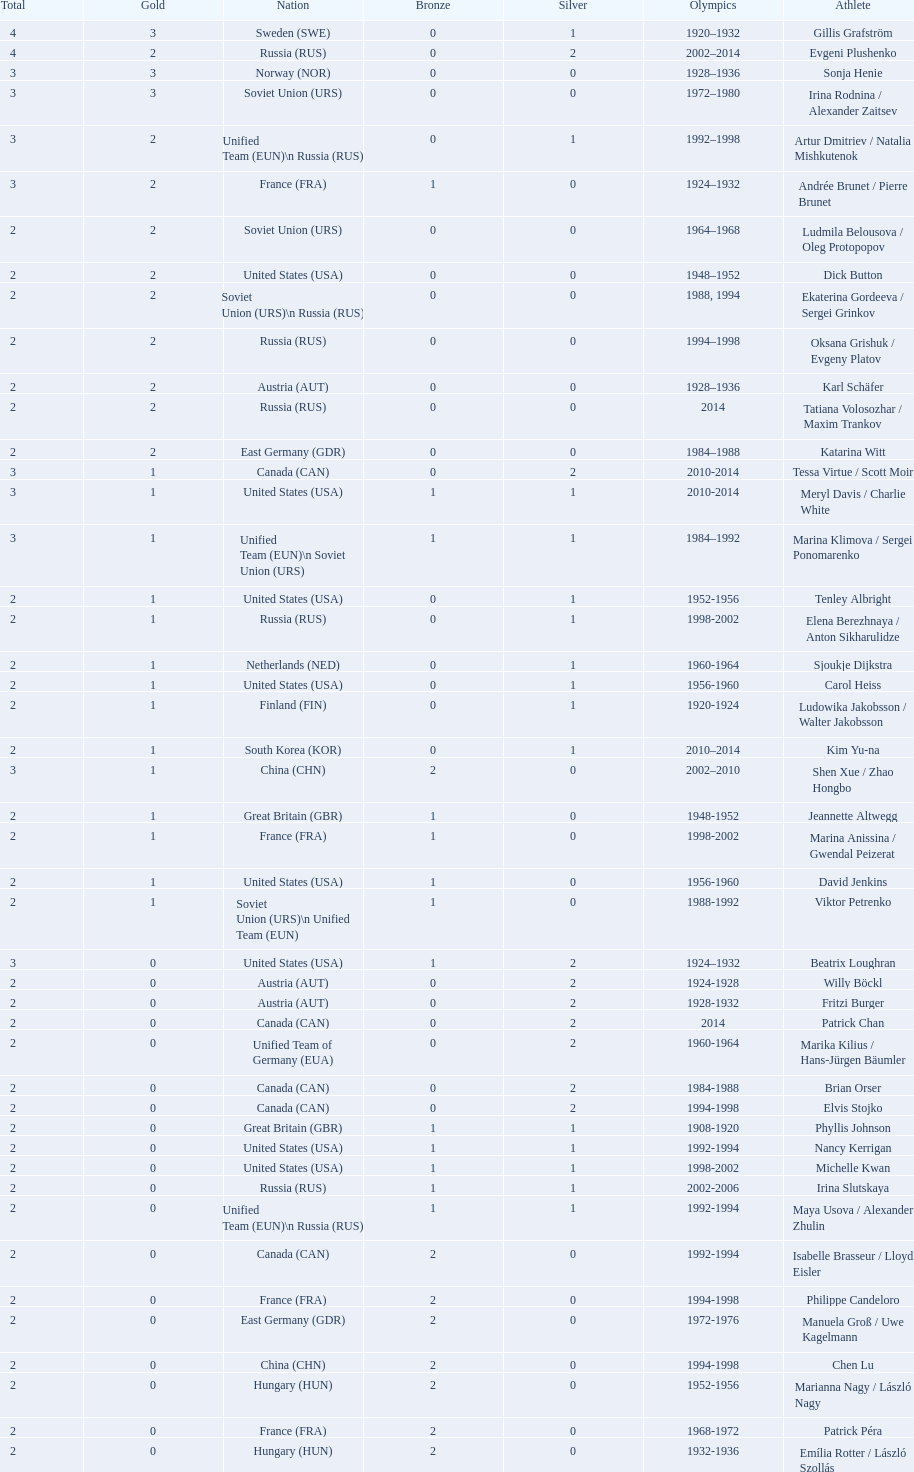How many more silver medals did gillis grafström have compared to sonja henie? 1. 